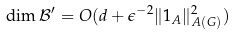Convert formula to latex. <formula><loc_0><loc_0><loc_500><loc_500>\dim \mathcal { B } ^ { \prime } = O ( d + \epsilon ^ { - 2 } \| 1 _ { A } \| _ { A ( G ) } ^ { 2 } )</formula> 